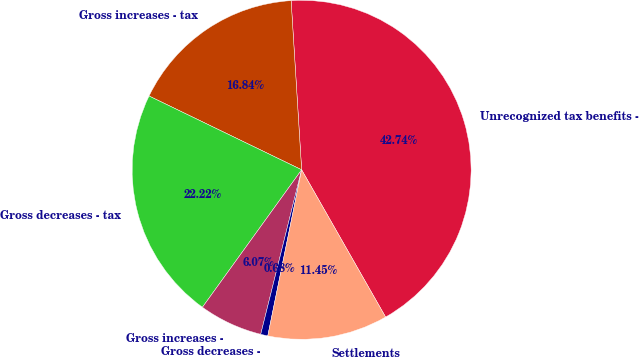<chart> <loc_0><loc_0><loc_500><loc_500><pie_chart><fcel>Unrecognized tax benefits -<fcel>Gross increases - tax<fcel>Gross decreases - tax<fcel>Gross increases -<fcel>Gross decreases -<fcel>Settlements<nl><fcel>42.74%<fcel>16.84%<fcel>22.22%<fcel>6.07%<fcel>0.68%<fcel>11.45%<nl></chart> 